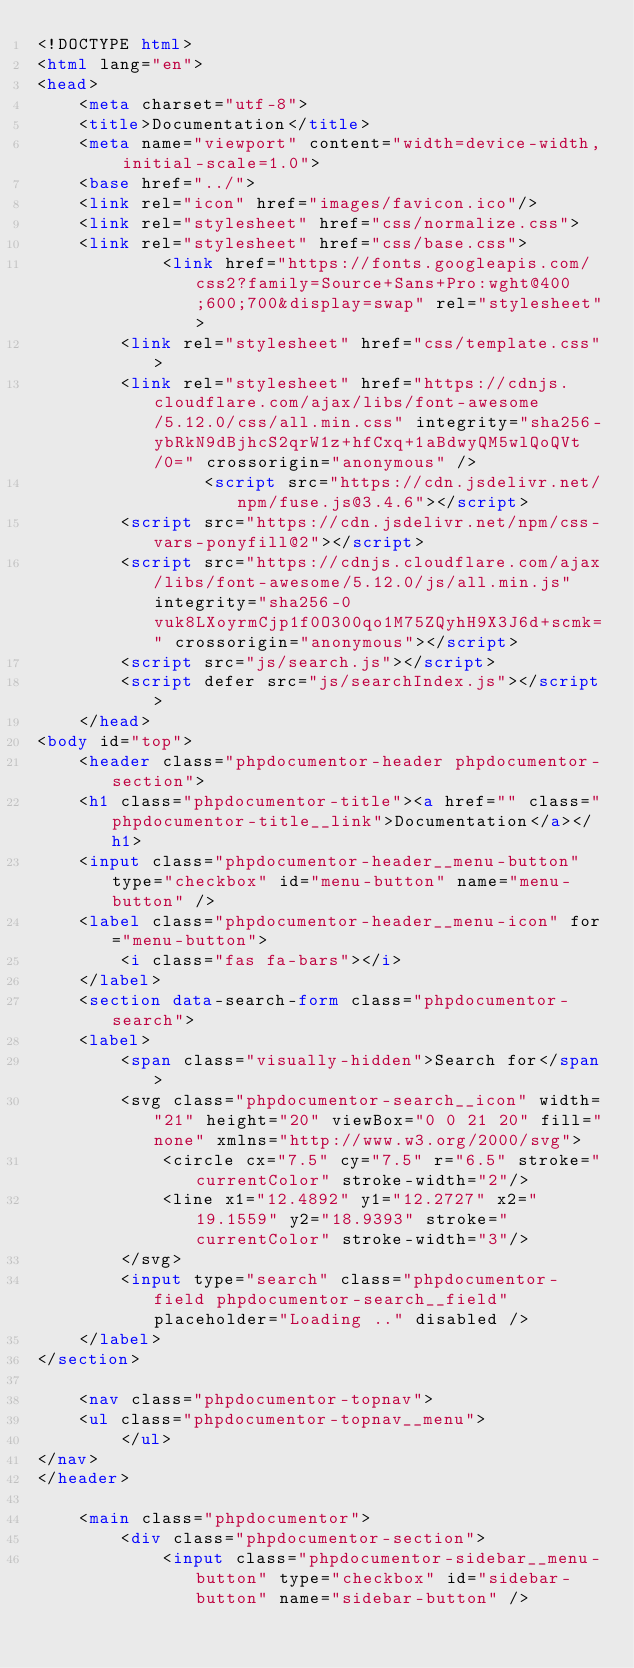Convert code to text. <code><loc_0><loc_0><loc_500><loc_500><_HTML_><!DOCTYPE html>
<html lang="en">
<head>
    <meta charset="utf-8">
    <title>Documentation</title>
    <meta name="viewport" content="width=device-width, initial-scale=1.0">
    <base href="../">
    <link rel="icon" href="images/favicon.ico"/>
    <link rel="stylesheet" href="css/normalize.css">
    <link rel="stylesheet" href="css/base.css">
            <link href="https://fonts.googleapis.com/css2?family=Source+Sans+Pro:wght@400;600;700&display=swap" rel="stylesheet">
        <link rel="stylesheet" href="css/template.css">
        <link rel="stylesheet" href="https://cdnjs.cloudflare.com/ajax/libs/font-awesome/5.12.0/css/all.min.css" integrity="sha256-ybRkN9dBjhcS2qrW1z+hfCxq+1aBdwyQM5wlQoQVt/0=" crossorigin="anonymous" />
                <script src="https://cdn.jsdelivr.net/npm/fuse.js@3.4.6"></script>
        <script src="https://cdn.jsdelivr.net/npm/css-vars-ponyfill@2"></script>
        <script src="https://cdnjs.cloudflare.com/ajax/libs/font-awesome/5.12.0/js/all.min.js" integrity="sha256-0vuk8LXoyrmCjp1f0O300qo1M75ZQyhH9X3J6d+scmk=" crossorigin="anonymous"></script>
        <script src="js/search.js"></script>
        <script defer src="js/searchIndex.js"></script>
    </head>
<body id="top">
    <header class="phpdocumentor-header phpdocumentor-section">
    <h1 class="phpdocumentor-title"><a href="" class="phpdocumentor-title__link">Documentation</a></h1>
    <input class="phpdocumentor-header__menu-button" type="checkbox" id="menu-button" name="menu-button" />
    <label class="phpdocumentor-header__menu-icon" for="menu-button">
        <i class="fas fa-bars"></i>
    </label>
    <section data-search-form class="phpdocumentor-search">
    <label>
        <span class="visually-hidden">Search for</span>
        <svg class="phpdocumentor-search__icon" width="21" height="20" viewBox="0 0 21 20" fill="none" xmlns="http://www.w3.org/2000/svg">
            <circle cx="7.5" cy="7.5" r="6.5" stroke="currentColor" stroke-width="2"/>
            <line x1="12.4892" y1="12.2727" x2="19.1559" y2="18.9393" stroke="currentColor" stroke-width="3"/>
        </svg>
        <input type="search" class="phpdocumentor-field phpdocumentor-search__field" placeholder="Loading .." disabled />
    </label>
</section>

    <nav class="phpdocumentor-topnav">
    <ul class="phpdocumentor-topnav__menu">
        </ul>
</nav>
</header>

    <main class="phpdocumentor">
        <div class="phpdocumentor-section">
            <input class="phpdocumentor-sidebar__menu-button" type="checkbox" id="sidebar-button" name="sidebar-button" /></code> 